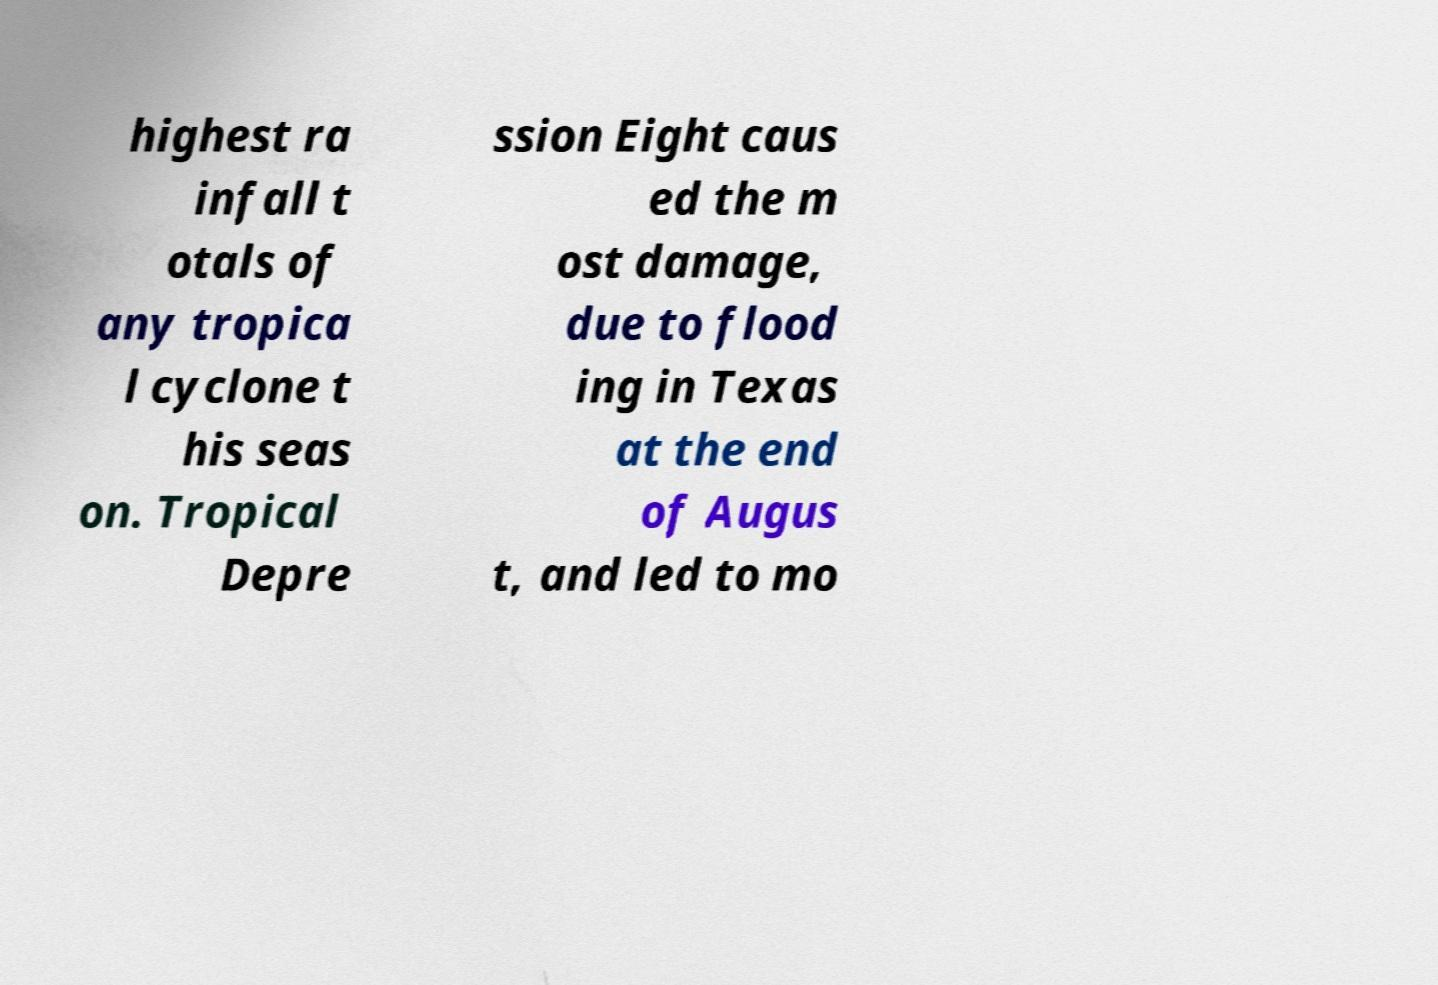Could you extract and type out the text from this image? highest ra infall t otals of any tropica l cyclone t his seas on. Tropical Depre ssion Eight caus ed the m ost damage, due to flood ing in Texas at the end of Augus t, and led to mo 